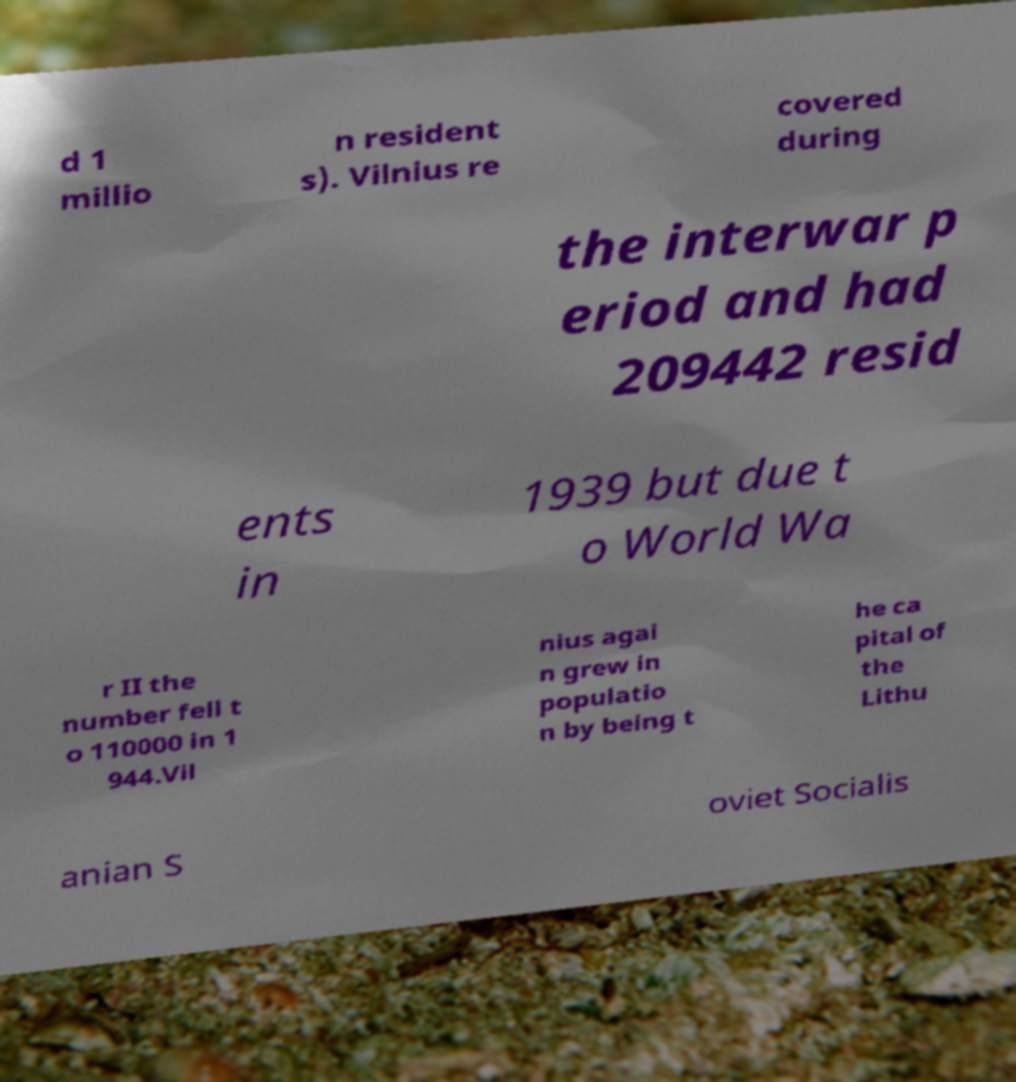For documentation purposes, I need the text within this image transcribed. Could you provide that? d 1 millio n resident s). Vilnius re covered during the interwar p eriod and had 209442 resid ents in 1939 but due t o World Wa r II the number fell t o 110000 in 1 944.Vil nius agai n grew in populatio n by being t he ca pital of the Lithu anian S oviet Socialis 